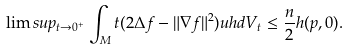Convert formula to latex. <formula><loc_0><loc_0><loc_500><loc_500>\lim s u p _ { t \to 0 ^ { + } } \int _ { M } t ( 2 \Delta f - \| \nabla f \| ^ { 2 } ) u h d V _ { t } \leq \frac { n } { 2 } h ( p , 0 ) .</formula> 